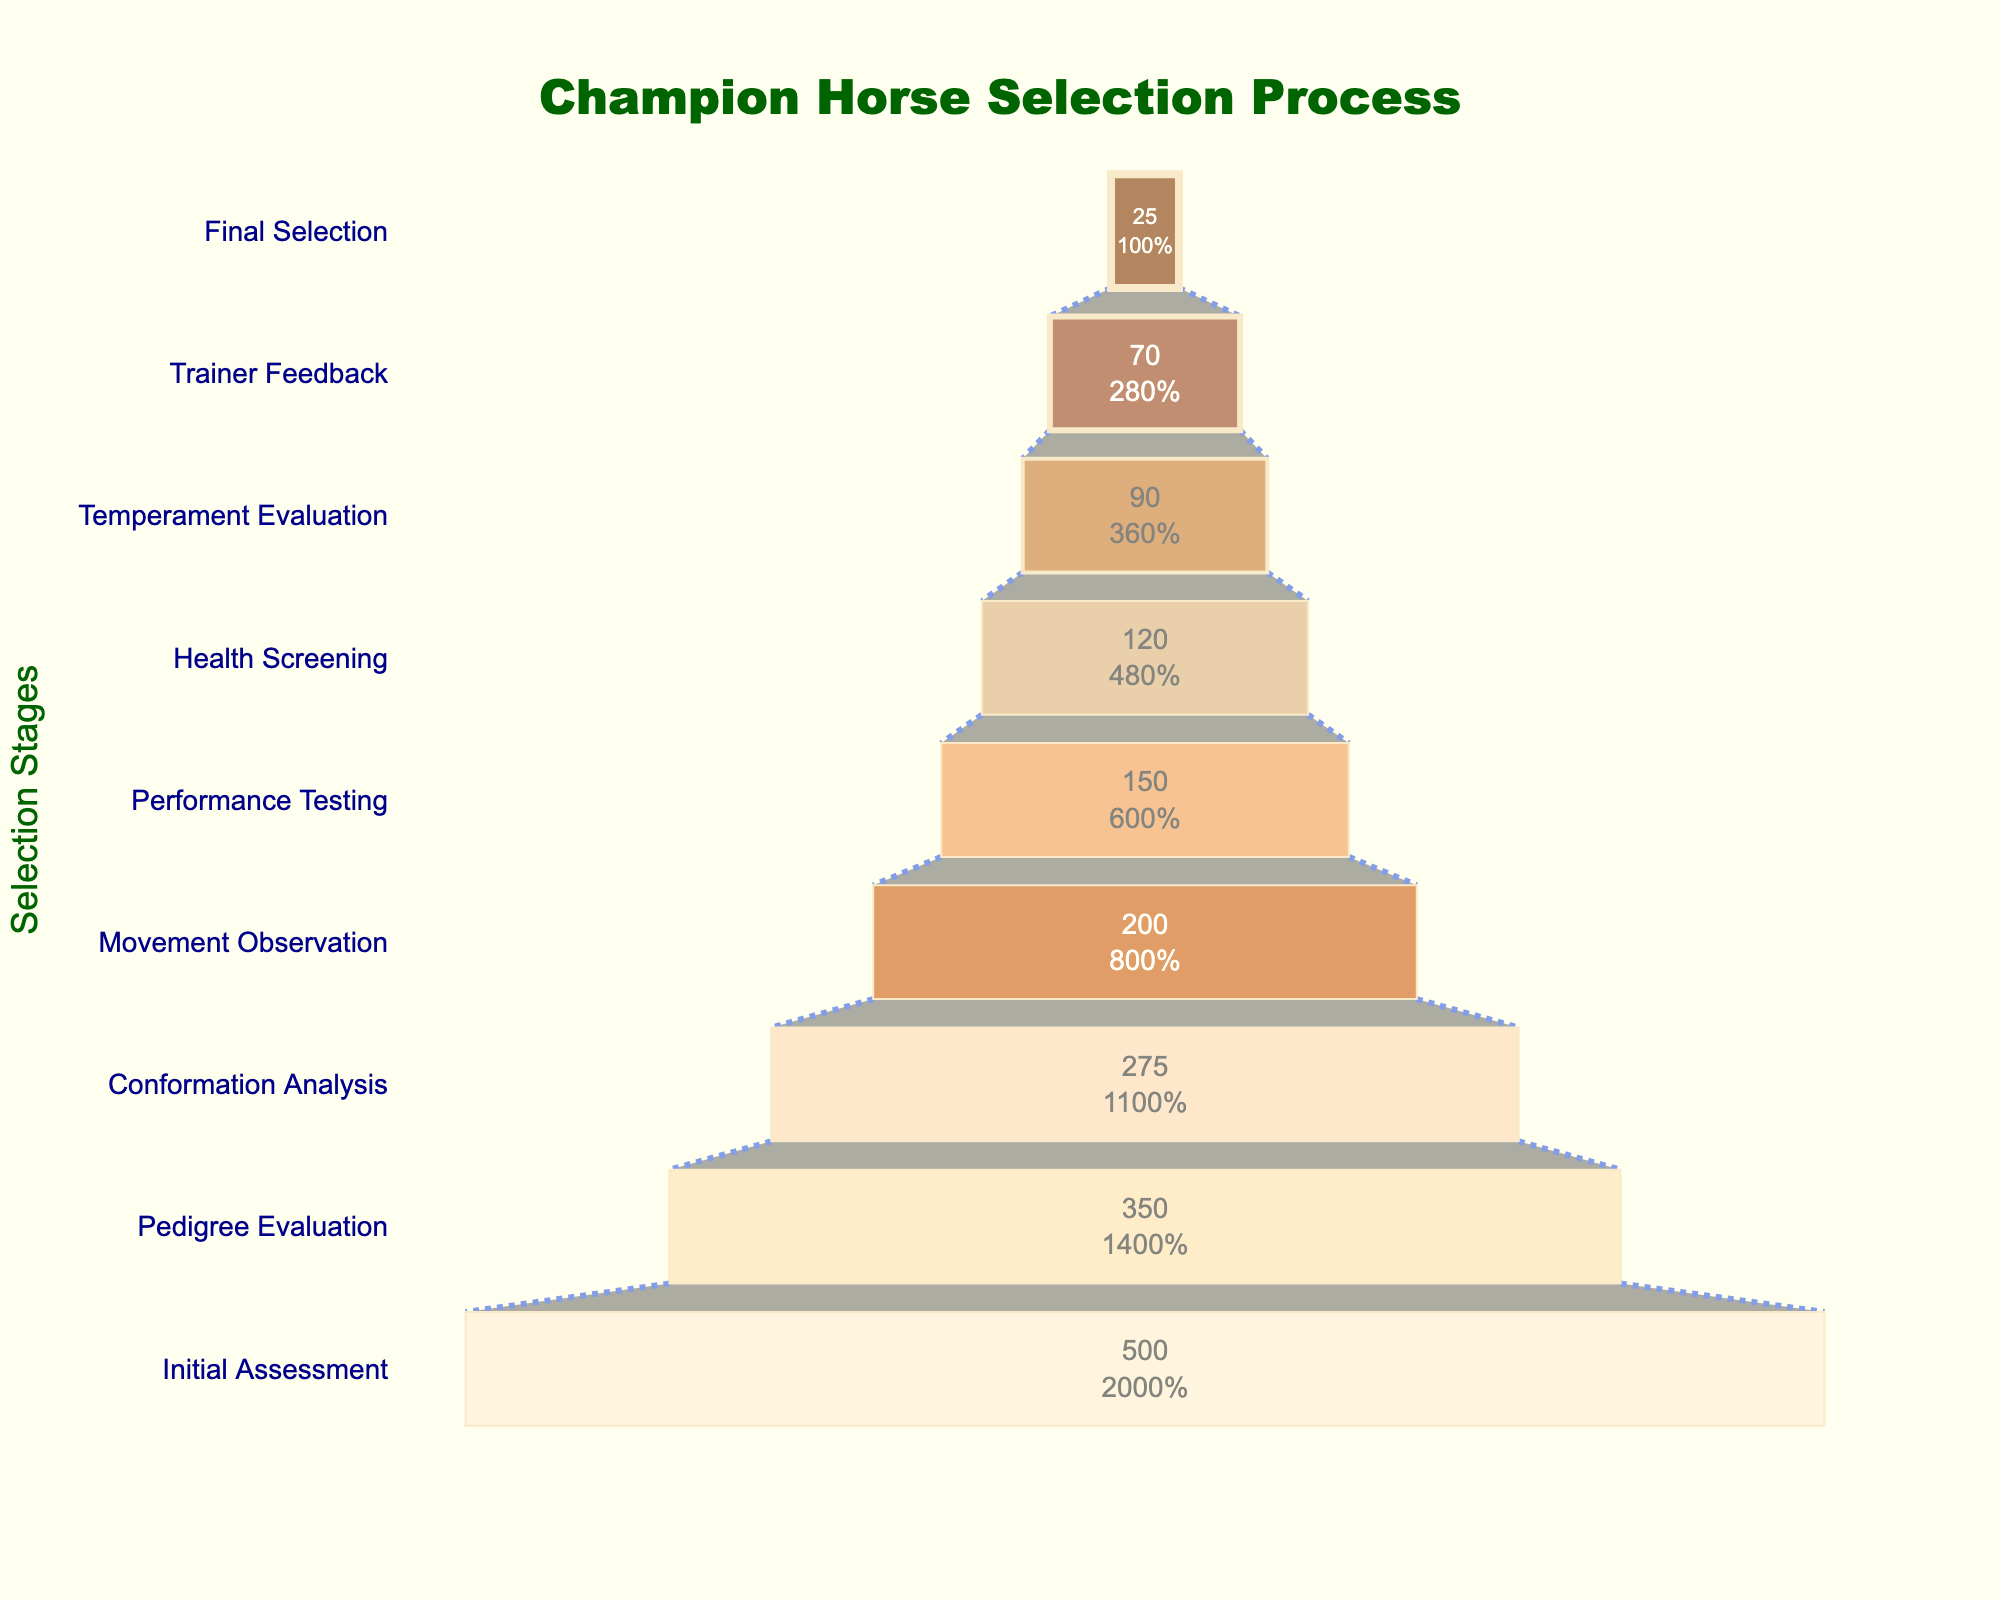what is the title of the figure? The title of the figure is prominently displayed at the top. It reads "Champion Horse Selection Process".
Answer: Champion Horse Selection Process At which stage do we see the highest number of horses? The highest number of horses is seen at the "Initial Assessment" stage, which is where the funnel starts. This stage shows 500 horses.
Answer: Initial Assessment How many stages are illustrated in the figure? By counting each unique stage listed in the funnel chart, it's clear there are a total of 9 stages.
Answer: 9 Which stage shows the largest absolute drop in the number of horses compared to the previous stage? To find the largest absolute drop, calculate the differences between consecutive stages: Initial Assessment to Pedigree Evaluation (500-350=150), Pedigree to Conformation (350-275=75), Conformation to Movement (275-200=75), Movement to Performance (200-150=50), Performance to Health (150-120=30), Health to Temperament (120-90=30), Temperament to Trainer (90-70=20), Trainer to Final (70-25=45). The largest drop is from Initial Assessment to Pedigree (150 horses).
Answer: Initial Assessment to Pedigree Evaluation What percent of horses make it to the Final Selection stage compared to Initial Assessment? To determine the percentage, divide the number of horses in the Final Selection by the number in the Initial Assessment, then multiply by 100. (25/500)*100 = 5%.
Answer: 5% Which stage has the smallest proportion of horses compared to the initial assessment? By comparing each stage to the initial assessment of 500 horses, the stage with the smallest fraction is the Final Selection. (25/500 = 0.05 or 5%).
Answer: Final Selection How many horses are evaluated after the Health Screening stage? After the Health Screening stage, the remaining stages are Temperament Evaluation, Trainer Feedback, and Final Selection, which account for (90, 70, and 25 horses respectively).
Answer: 90 What is the average number of horses per stage from Movement Observation onward? Summing the number of horses from Movement Observation (200), Performance Testing (150), Health Screening (120), Temperament Evaluation (90), Trainer Feedback (70), Final Selection (25) = 655. There are 6 stages, so the average is 655/6 ≈ 109.2.
Answer: ~109.2 At which stage do less than a quarter of the initial horses remain? Less than a quarter of the initial 500 horses means fewer than 125. By observing the chart, the "Health Screening" stage has fewer than 120 horses, starting from this stage and beyond.
Answer: Health Screening What is the percentage decrease from Conformation Analysis to Movement Observation? Conformation Analysis has 275 horses and Movement Observation has 200. The percentage decrease is calculated by (275-200)/275 * 100 = 27.27%.
Answer: 27.27% 